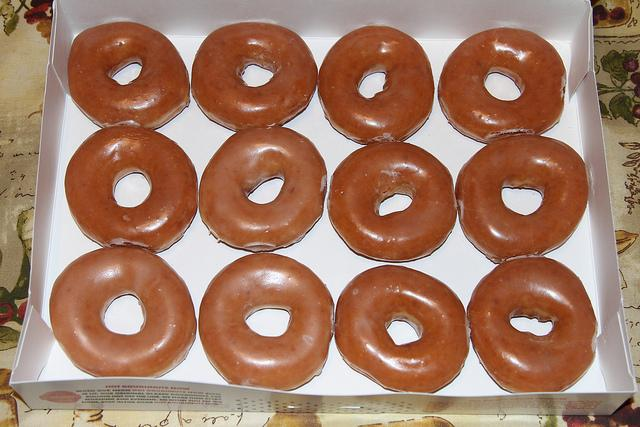What type of coating is found on the paper below the donuts? Please explain your reasoning. wax. Donuts can get sticky. it is a non-stick coating. 